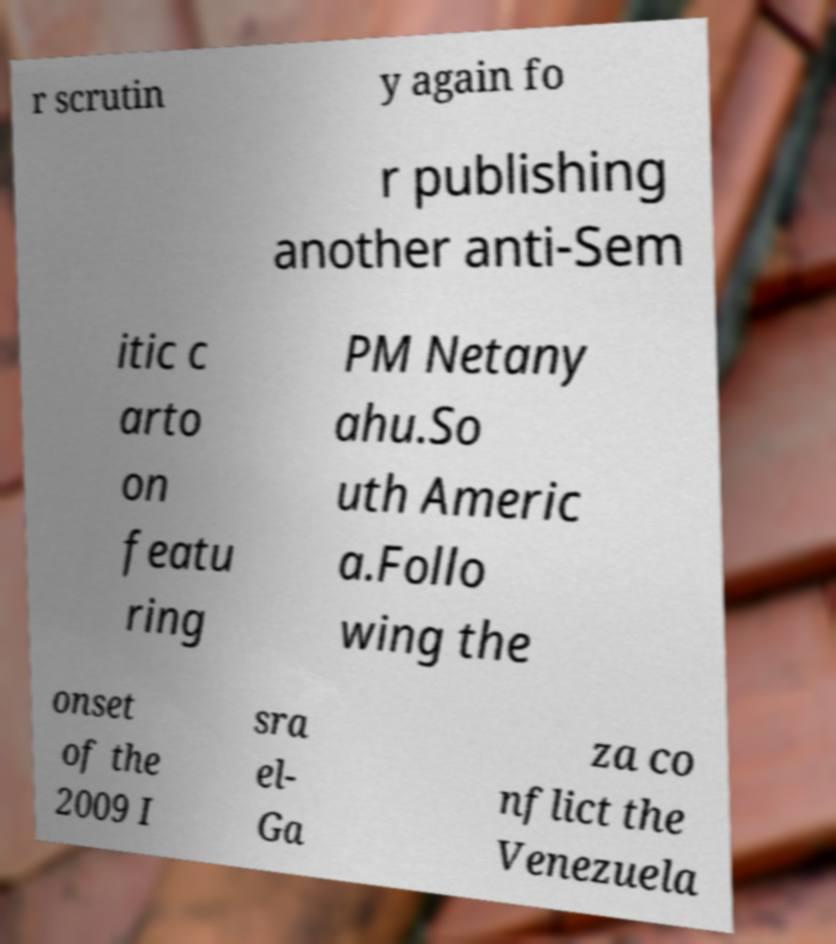I need the written content from this picture converted into text. Can you do that? r scrutin y again fo r publishing another anti-Sem itic c arto on featu ring PM Netany ahu.So uth Americ a.Follo wing the onset of the 2009 I sra el- Ga za co nflict the Venezuela 